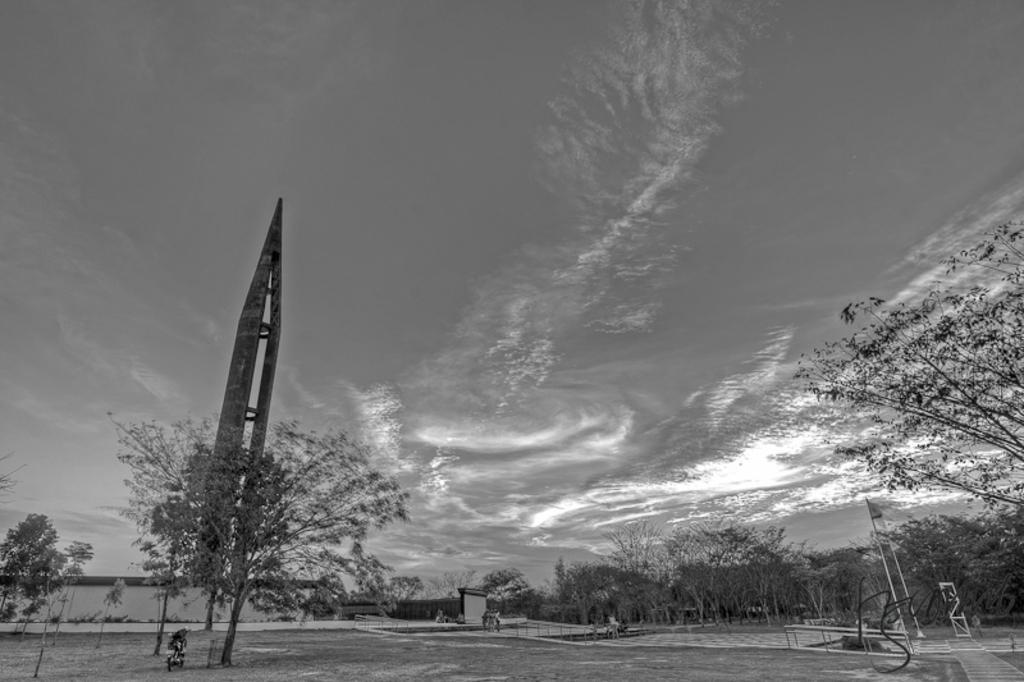In one or two sentences, can you explain what this image depicts? In this picture we can see some trees, on the right side there are two poles, it looks like a tower on the left side, in the background there is a wall, we can see the sky at the top of the picture. 